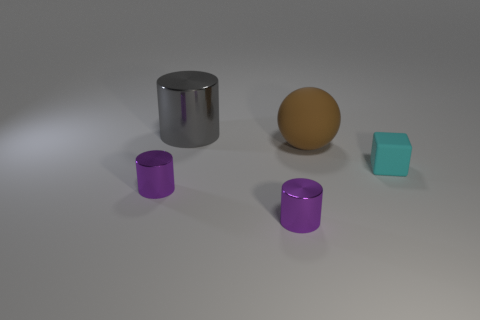Are there fewer small purple metallic objects than small objects?
Provide a succinct answer. Yes. There is a tiny metal cylinder on the left side of the large gray metal cylinder; is there a purple object on the right side of it?
Provide a succinct answer. Yes. Are there any cylinders that are on the left side of the tiny metal cylinder behind the purple object that is on the right side of the big gray thing?
Your answer should be very brief. No. There is a large object behind the sphere; does it have the same shape as the purple object that is left of the gray cylinder?
Provide a short and direct response. Yes. What color is the small cube that is made of the same material as the big ball?
Ensure brevity in your answer.  Cyan. Are there fewer tiny cylinders that are on the right side of the gray thing than large cyan metallic balls?
Offer a very short reply. No. What size is the brown sphere behind the tiny shiny object that is on the left side of the small purple object that is on the right side of the gray cylinder?
Keep it short and to the point. Large. Is the material of the small object left of the large cylinder the same as the large cylinder?
Your answer should be very brief. Yes. Are there any other things that are the same shape as the brown matte thing?
Your answer should be very brief. No. How many objects are either big brown metallic balls or big gray things?
Your answer should be compact. 1. 